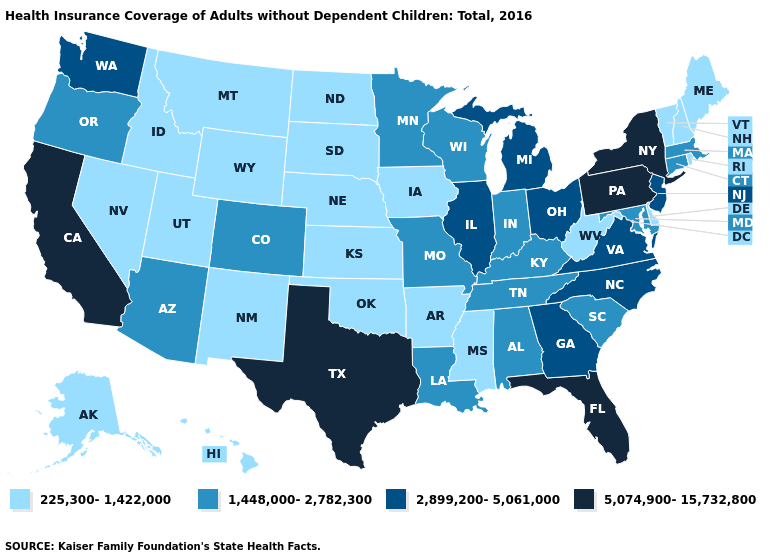What is the highest value in the USA?
Be succinct. 5,074,900-15,732,800. Does Florida have the lowest value in the USA?
Keep it brief. No. What is the highest value in the USA?
Answer briefly. 5,074,900-15,732,800. Name the states that have a value in the range 225,300-1,422,000?
Keep it brief. Alaska, Arkansas, Delaware, Hawaii, Idaho, Iowa, Kansas, Maine, Mississippi, Montana, Nebraska, Nevada, New Hampshire, New Mexico, North Dakota, Oklahoma, Rhode Island, South Dakota, Utah, Vermont, West Virginia, Wyoming. What is the value of Massachusetts?
Short answer required. 1,448,000-2,782,300. Name the states that have a value in the range 2,899,200-5,061,000?
Quick response, please. Georgia, Illinois, Michigan, New Jersey, North Carolina, Ohio, Virginia, Washington. Name the states that have a value in the range 2,899,200-5,061,000?
Be succinct. Georgia, Illinois, Michigan, New Jersey, North Carolina, Ohio, Virginia, Washington. Name the states that have a value in the range 5,074,900-15,732,800?
Answer briefly. California, Florida, New York, Pennsylvania, Texas. Which states hav the highest value in the MidWest?
Be succinct. Illinois, Michigan, Ohio. Which states have the lowest value in the USA?
Give a very brief answer. Alaska, Arkansas, Delaware, Hawaii, Idaho, Iowa, Kansas, Maine, Mississippi, Montana, Nebraska, Nevada, New Hampshire, New Mexico, North Dakota, Oklahoma, Rhode Island, South Dakota, Utah, Vermont, West Virginia, Wyoming. Does Vermont have the lowest value in the USA?
Concise answer only. Yes. What is the highest value in the USA?
Concise answer only. 5,074,900-15,732,800. Which states have the lowest value in the West?
Give a very brief answer. Alaska, Hawaii, Idaho, Montana, Nevada, New Mexico, Utah, Wyoming. What is the highest value in states that border South Dakota?
Concise answer only. 1,448,000-2,782,300. What is the value of Tennessee?
Concise answer only. 1,448,000-2,782,300. 